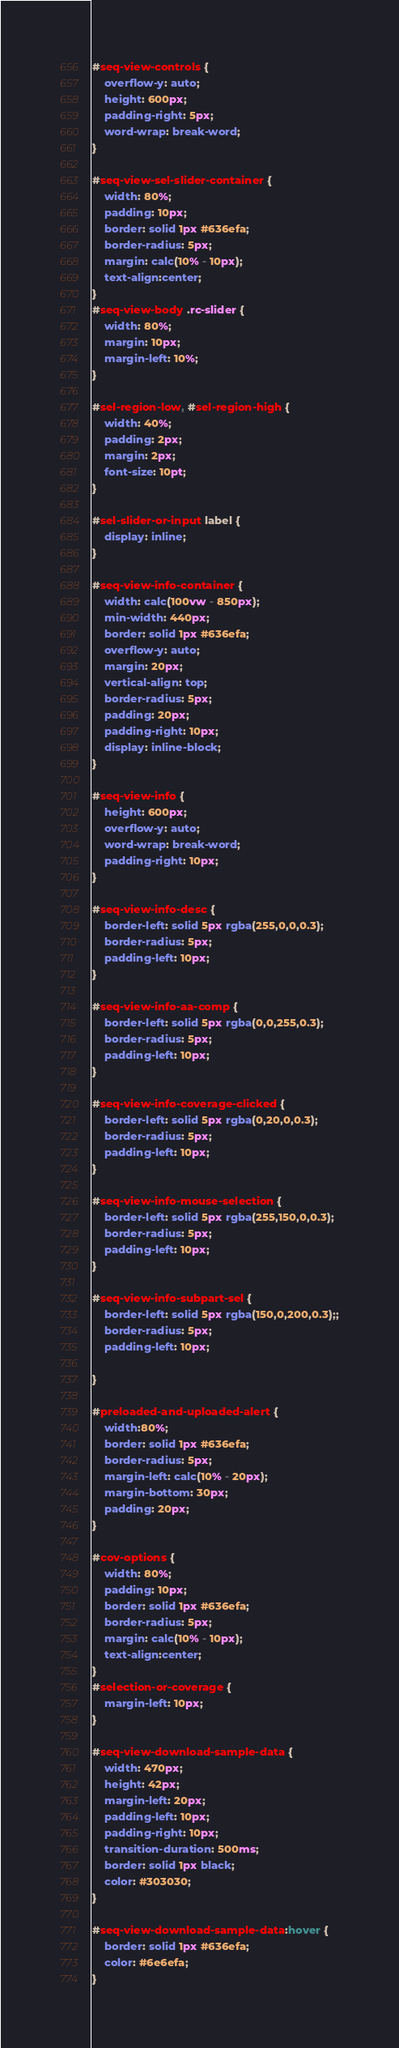<code> <loc_0><loc_0><loc_500><loc_500><_CSS_>#seq-view-controls {
    overflow-y: auto;
    height: 600px;
    padding-right: 5px;
    word-wrap: break-word;
}

#seq-view-sel-slider-container {
    width: 80%;
    padding: 10px;
    border: solid 1px #636efa; 
    border-radius: 5px;
    margin: calc(10% - 10px); 
    text-align:center;
}
#seq-view-body .rc-slider {
    width: 80%;
    margin: 10px;
    margin-left: 10%;
}

#sel-region-low, #sel-region-high {
    width: 40%;
    padding: 2px;
    margin: 2px; 
    font-size: 10pt; 
}

#sel-slider-or-input label {
    display: inline; 
} 

#seq-view-info-container {
    width: calc(100vw - 850px);
    min-width: 440px; 
    border: solid 1px #636efa; 
    overflow-y: auto;
    margin: 20px;
    vertical-align: top; 
    border-radius: 5px;
    padding: 20px;
    padding-right: 10px; 
    display: inline-block;
}

#seq-view-info {
    height: 600px;
    overflow-y: auto;
    word-wrap: break-word;
    padding-right: 10px; 
}

#seq-view-info-desc {
    border-left: solid 5px rgba(255,0,0,0.3);
    border-radius: 5px;
    padding-left: 10px; 
}

#seq-view-info-aa-comp {
    border-left: solid 5px rgba(0,0,255,0.3); 
    border-radius: 5px;
    padding-left: 10px; 
}

#seq-view-info-coverage-clicked {
    border-left: solid 5px rgba(0,20,0,0.3);
    border-radius: 5px;
    padding-left: 10px; 
}

#seq-view-info-mouse-selection {
    border-left: solid 5px rgba(255,150,0,0.3);
    border-radius: 5px;
    padding-left: 10px; 
}

#seq-view-info-subpart-sel {
    border-left: solid 5px rgba(150,0,200,0.3);;
    border-radius: 5px;
    padding-left: 10px; 

}

#preloaded-and-uploaded-alert {
    width:80%;
    border: solid 1px #636efa;
    border-radius: 5px;
    margin-left: calc(10% - 20px);
    margin-bottom: 30px; 
    padding: 20px; 
}

#cov-options {
    width: 80%;
    padding: 10px;
    border: solid 1px #636efa; 
    border-radius: 5px;
    margin: calc(10% - 10px); 
    text-align:center;
}
#selection-or-coverage {
    margin-left: 10px;
}

#seq-view-download-sample-data {
    width: 470px;
    height: 42px;
    margin-left: 20px;
    padding-left: 10px;
    padding-right: 10px; 
    transition-duration: 500ms;
    border: solid 1px black;
    color: #303030;
} 

#seq-view-download-sample-data:hover {
    border: solid 1px #636efa;
    color: #6e6efa;
}
</code> 